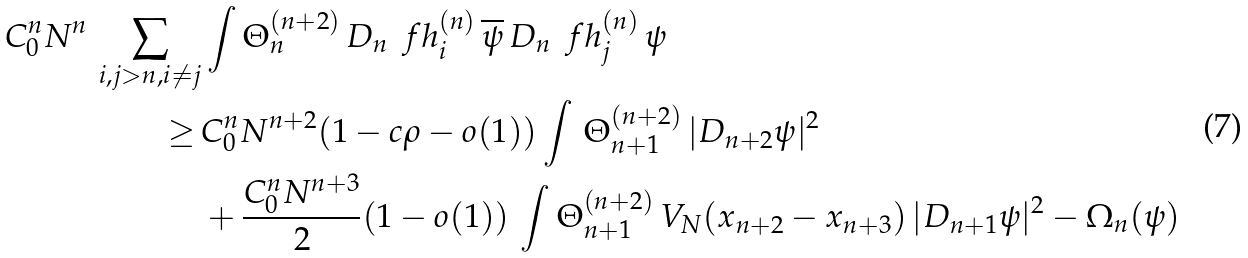<formula> <loc_0><loc_0><loc_500><loc_500>C _ { 0 } ^ { n } N ^ { n } \, \sum _ { i , j > n , i \neq j } & \int \Theta ^ { ( n + 2 ) } _ { n } \, D _ { n } \, \ f h ^ { ( n ) } _ { i } \, \overline { \psi } \, D _ { n } \, \ f h ^ { ( n ) } _ { j } \, \psi \\ \geq \, & C _ { 0 } ^ { n } N ^ { n + 2 } ( 1 - c \rho - o ( 1 ) ) \int \, \Theta ^ { ( n + 2 ) } _ { n + 1 } \, | D _ { n + 2 } \psi | ^ { 2 } \\ & + \frac { C _ { 0 } ^ { n } N ^ { n + 3 } } { 2 } ( 1 - o ( 1 ) ) \, \int \Theta ^ { ( n + 2 ) } _ { n + 1 } \, V _ { N } ( x _ { n + 2 } - x _ { n + 3 } ) \, | D _ { n + 1 } \psi | ^ { 2 } - \Omega _ { n } ( \psi )</formula> 